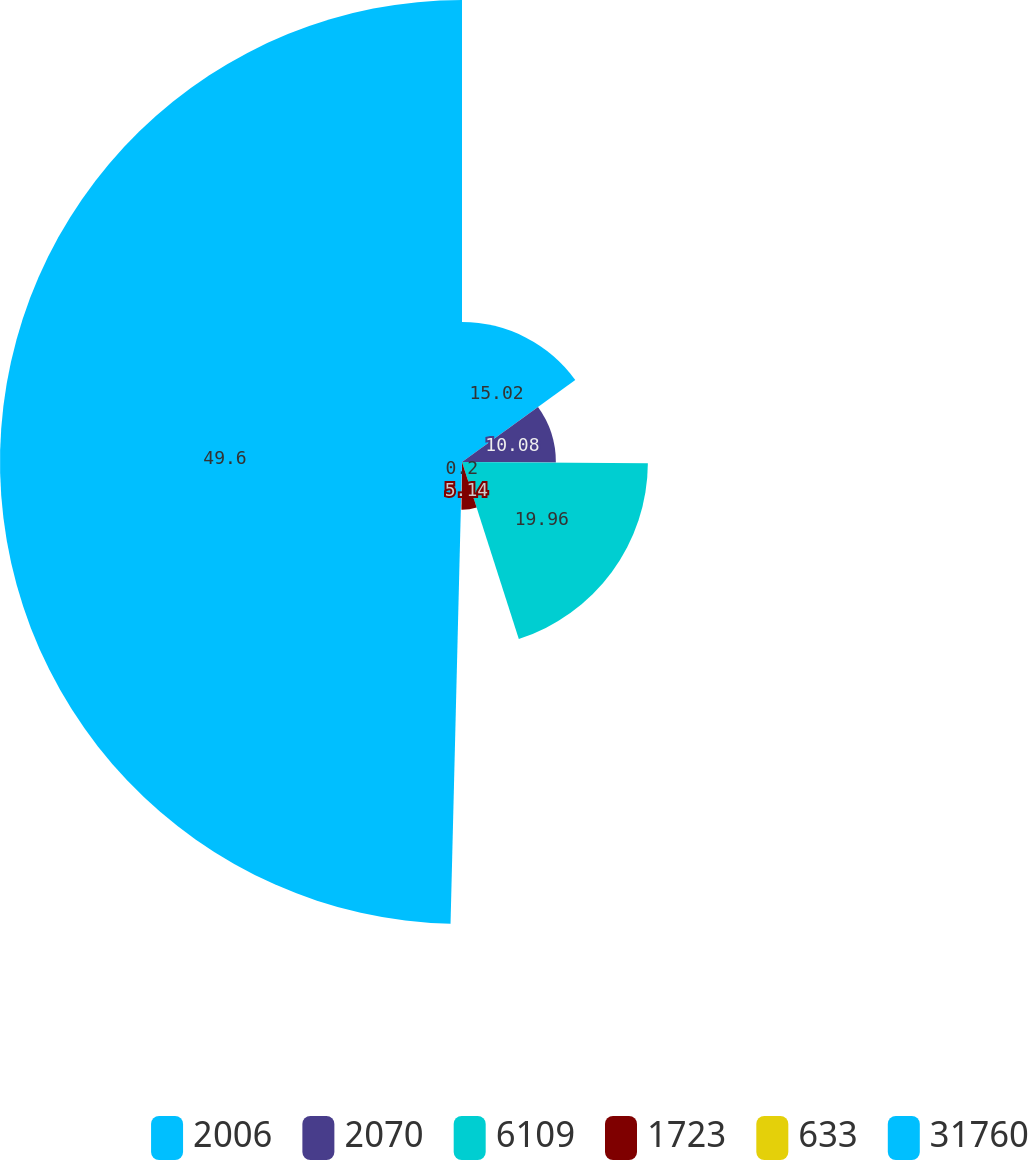Convert chart. <chart><loc_0><loc_0><loc_500><loc_500><pie_chart><fcel>2006<fcel>2070<fcel>6109<fcel>1723<fcel>633<fcel>31760<nl><fcel>15.02%<fcel>10.08%<fcel>19.96%<fcel>5.14%<fcel>0.2%<fcel>49.61%<nl></chart> 